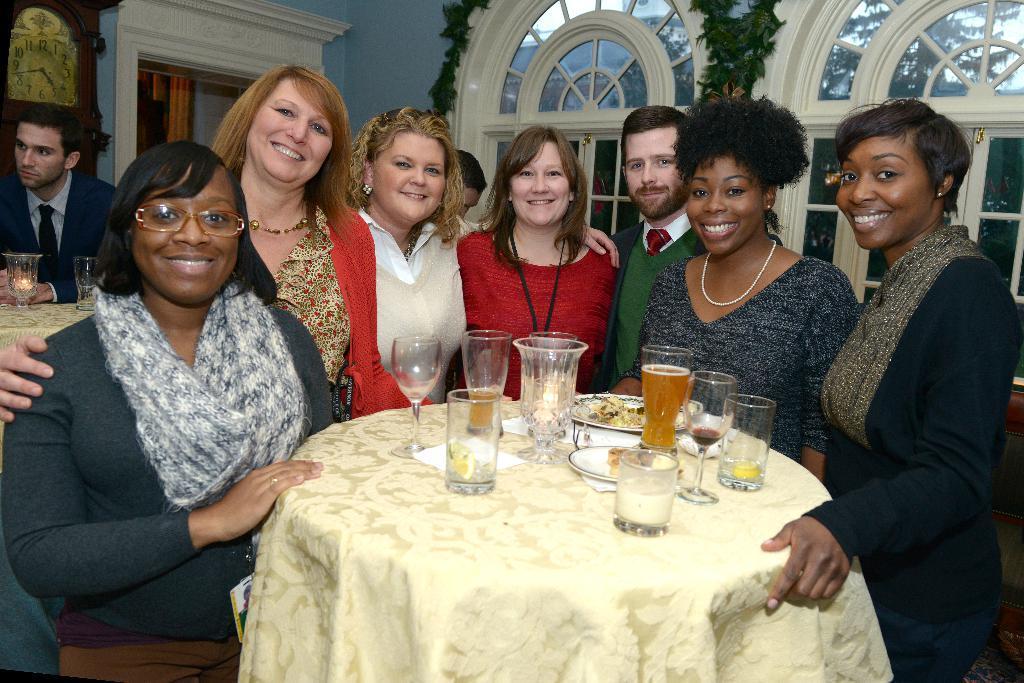Could you give a brief overview of what you see in this image? In the middle of the image there is a table on the table there is a plate and there are some glasses. Surrounding the table few people are standing and smiling. Behind them there is a window. Top left side of the image there is a clock. 